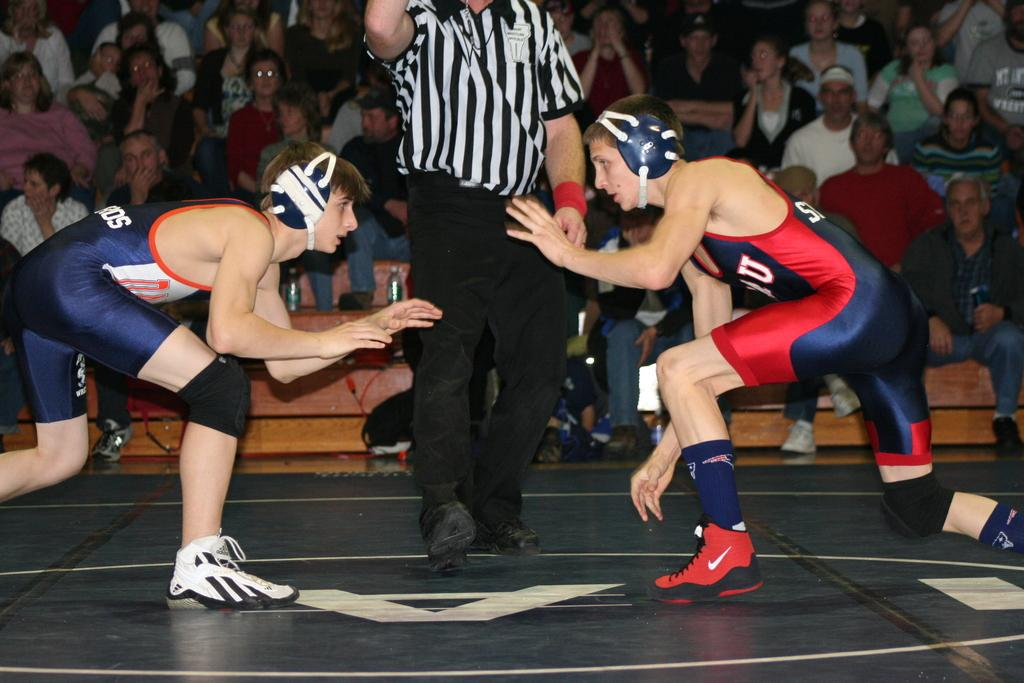<image>
Provide a brief description of the given image. a couple of wrestlers getting ready to fight with the letter A under them 